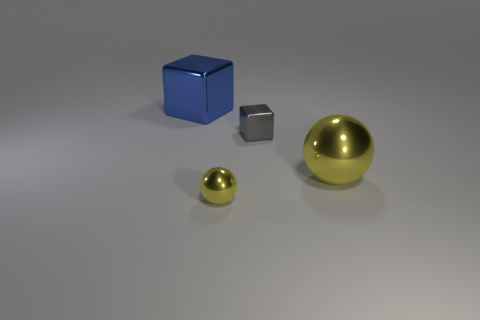Is the tiny shiny ball the same color as the big shiny ball?
Make the answer very short. Yes. What is the shape of the small object that is the same color as the large shiny ball?
Provide a short and direct response. Sphere. There is another shiny ball that is the same color as the large sphere; what is its size?
Keep it short and to the point. Small. There is a metal cube to the left of the yellow metal ball to the left of the large metal object in front of the blue metallic thing; what is its size?
Your answer should be compact. Large. What number of red spheres have the same material as the large yellow object?
Your response must be concise. 0. What number of other things are the same size as the blue metallic thing?
Your response must be concise. 1. What number of objects are big cyan rubber balls or small shiny balls?
Offer a very short reply. 1. The blue thing is what shape?
Offer a terse response. Cube. What is the shape of the shiny object left of the yellow object left of the gray block?
Provide a short and direct response. Cube. Is the sphere to the left of the tiny gray object made of the same material as the big blue object?
Offer a very short reply. Yes. 